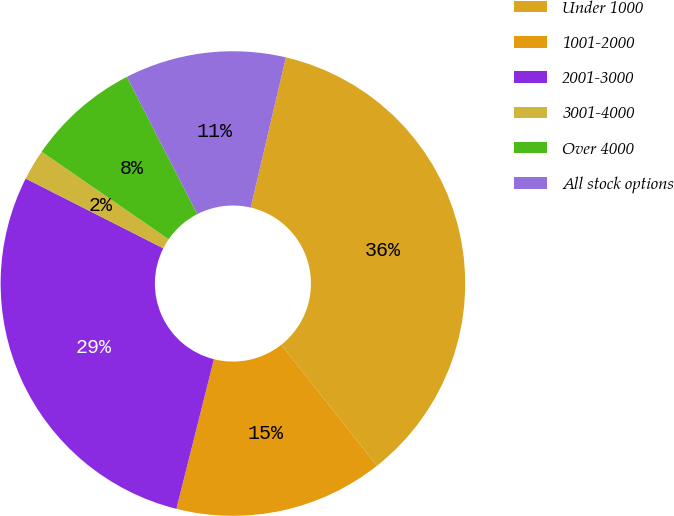<chart> <loc_0><loc_0><loc_500><loc_500><pie_chart><fcel>Under 1000<fcel>1001-2000<fcel>2001-3000<fcel>3001-4000<fcel>Over 4000<fcel>All stock options<nl><fcel>35.69%<fcel>14.56%<fcel>28.55%<fcel>2.14%<fcel>7.85%<fcel>11.21%<nl></chart> 